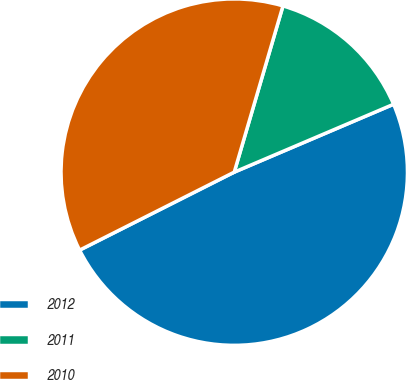Convert chart. <chart><loc_0><loc_0><loc_500><loc_500><pie_chart><fcel>2012<fcel>2011<fcel>2010<nl><fcel>48.97%<fcel>14.05%<fcel>36.97%<nl></chart> 